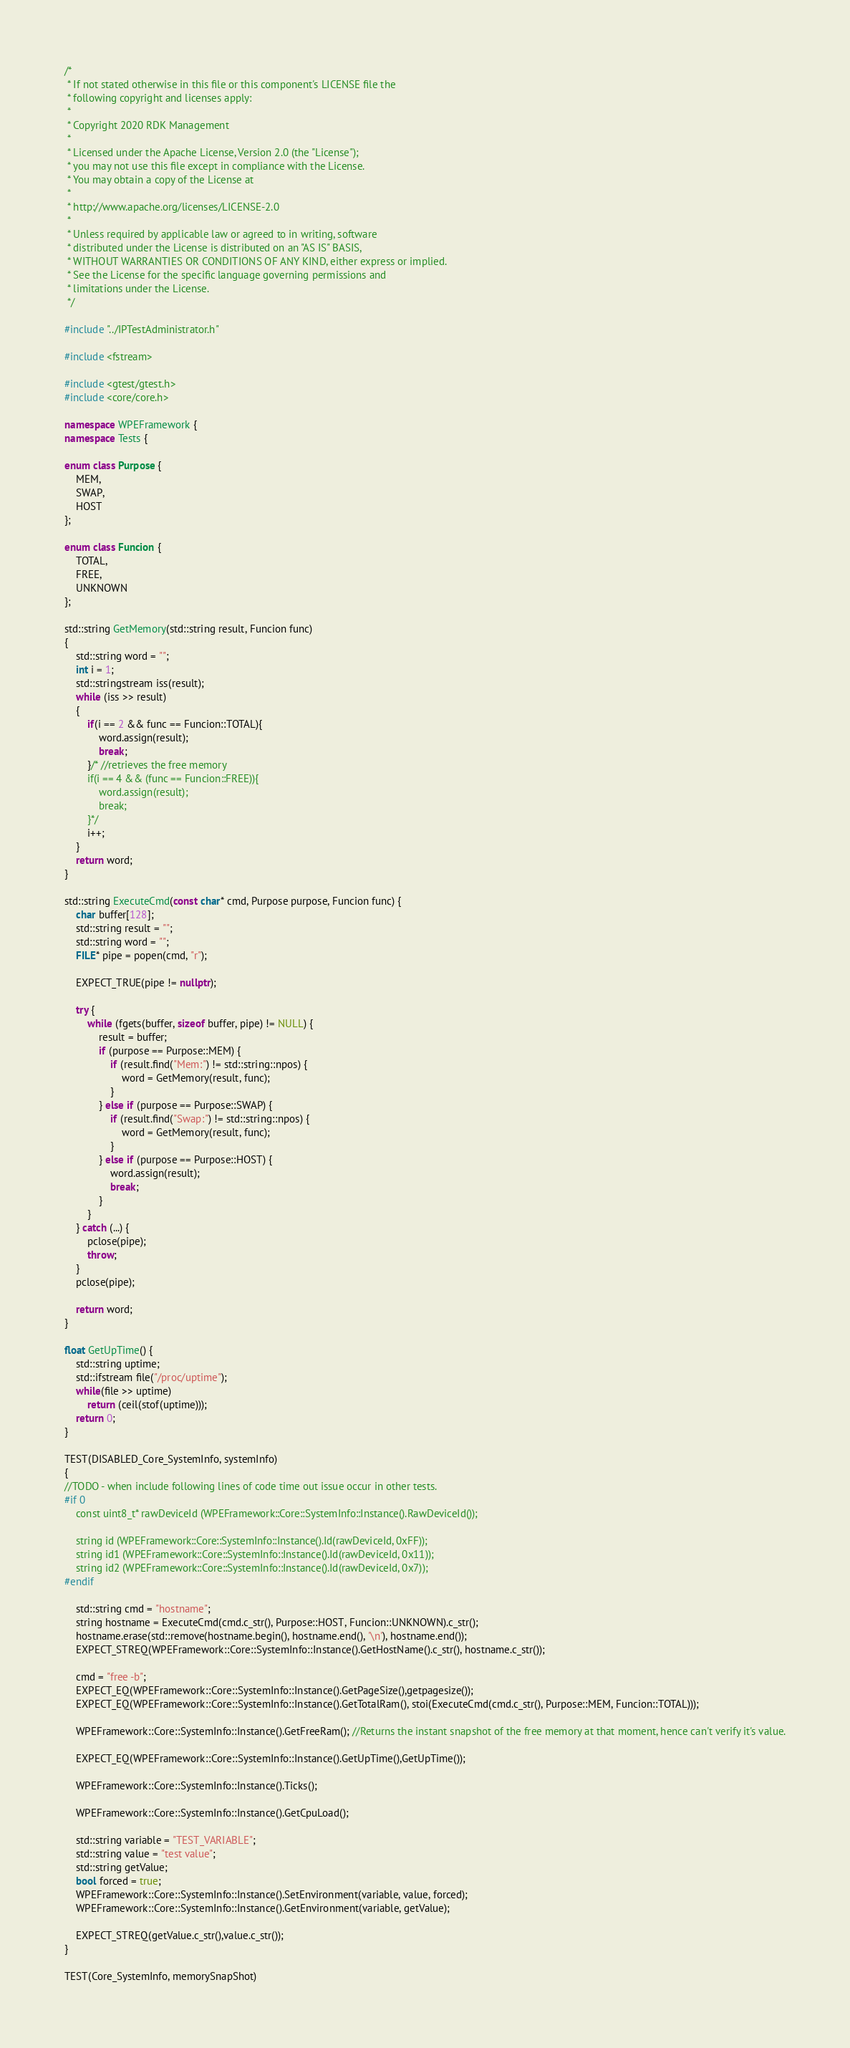<code> <loc_0><loc_0><loc_500><loc_500><_C++_>/*
 * If not stated otherwise in this file or this component's LICENSE file the
 * following copyright and licenses apply:
 *
 * Copyright 2020 RDK Management
 *
 * Licensed under the Apache License, Version 2.0 (the "License");
 * you may not use this file except in compliance with the License.
 * You may obtain a copy of the License at
 *
 * http://www.apache.org/licenses/LICENSE-2.0
 *
 * Unless required by applicable law or agreed to in writing, software
 * distributed under the License is distributed on an "AS IS" BASIS,
 * WITHOUT WARRANTIES OR CONDITIONS OF ANY KIND, either express or implied.
 * See the License for the specific language governing permissions and
 * limitations under the License.
 */

#include "../IPTestAdministrator.h"

#include <fstream>

#include <gtest/gtest.h>
#include <core/core.h>

namespace WPEFramework {
namespace Tests {

enum class Purpose {
    MEM,
    SWAP,
    HOST
};

enum class Funcion {
    TOTAL,
    FREE,
    UNKNOWN
};

std::string GetMemory(std::string result, Funcion func)
{
    std::string word = "";
    int i = 1;
    std::stringstream iss(result);
    while (iss >> result)
    {
        if(i == 2 && func == Funcion::TOTAL){
            word.assign(result);
            break;
        }/* //retrieves the free memory
        if(i == 4 && (func == Funcion::FREE)){
            word.assign(result);
            break;
        }*/
        i++;
    }
    return word;
}

std::string ExecuteCmd(const char* cmd, Purpose purpose, Funcion func) {
    char buffer[128];
    std::string result = "";
    std::string word = "";
    FILE* pipe = popen(cmd, "r");

    EXPECT_TRUE(pipe != nullptr);

    try {
        while (fgets(buffer, sizeof buffer, pipe) != NULL) {
            result = buffer;
            if (purpose == Purpose::MEM) {
                if (result.find("Mem:") != std::string::npos) {
                    word = GetMemory(result, func);
                }
            } else if (purpose == Purpose::SWAP) {
                if (result.find("Swap:") != std::string::npos) {
                    word = GetMemory(result, func);
                }
            } else if (purpose == Purpose::HOST) {
                word.assign(result);
                break;
            }
        }
    } catch (...) {
        pclose(pipe);
        throw;
    }
    pclose(pipe);

    return word;
}

float GetUpTime() {
    std::string uptime;
    std::ifstream file("/proc/uptime");
    while(file >> uptime)
        return (ceil(stof(uptime)));
    return 0;
}

TEST(DISABLED_Core_SystemInfo, systemInfo)
{
//TODO - when include following lines of code time out issue occur in other tests.
#if 0
    const uint8_t* rawDeviceId (WPEFramework::Core::SystemInfo::Instance().RawDeviceId());

    string id (WPEFramework::Core::SystemInfo::Instance().Id(rawDeviceId, 0xFF));
    string id1 (WPEFramework::Core::SystemInfo::Instance().Id(rawDeviceId, 0x11));
    string id2 (WPEFramework::Core::SystemInfo::Instance().Id(rawDeviceId, 0x7));
#endif

    std::string cmd = "hostname";
    string hostname = ExecuteCmd(cmd.c_str(), Purpose::HOST, Funcion::UNKNOWN).c_str();
    hostname.erase(std::remove(hostname.begin(), hostname.end(), '\n'), hostname.end());
    EXPECT_STREQ(WPEFramework::Core::SystemInfo::Instance().GetHostName().c_str(), hostname.c_str());

    cmd = "free -b";
    EXPECT_EQ(WPEFramework::Core::SystemInfo::Instance().GetPageSize(),getpagesize());
    EXPECT_EQ(WPEFramework::Core::SystemInfo::Instance().GetTotalRam(), stoi(ExecuteCmd(cmd.c_str(), Purpose::MEM, Funcion::TOTAL)));

    WPEFramework::Core::SystemInfo::Instance().GetFreeRam(); //Returns the instant snapshot of the free memory at that moment, hence can't verify it's value.

    EXPECT_EQ(WPEFramework::Core::SystemInfo::Instance().GetUpTime(),GetUpTime());

    WPEFramework::Core::SystemInfo::Instance().Ticks();

    WPEFramework::Core::SystemInfo::Instance().GetCpuLoad();

    std::string variable = "TEST_VARIABLE";
    std::string value = "test value";
    std::string getValue;
    bool forced = true;
    WPEFramework::Core::SystemInfo::Instance().SetEnvironment(variable, value, forced);
    WPEFramework::Core::SystemInfo::Instance().GetEnvironment(variable, getValue);

    EXPECT_STREQ(getValue.c_str(),value.c_str());
}

TEST(Core_SystemInfo, memorySnapShot)</code> 